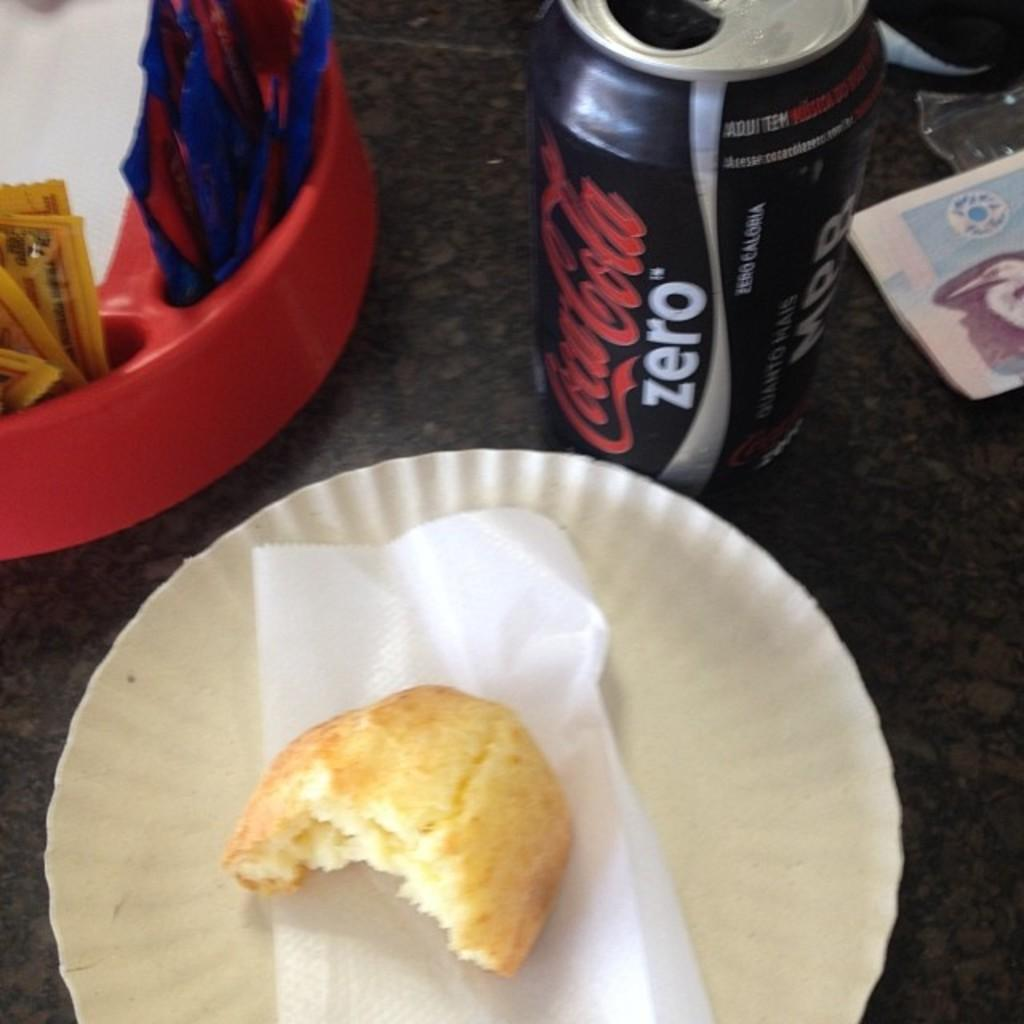What is on the floor in the image? There is a plate with a food item and a coke tin on the floor. Are there any other objects on the floor? Yes, there are other objects on the floor. What type of map can be seen on the floor in the image? There is no map present in the image; it only shows a plate with a food item, a coke tin, and other objects on the floor. 